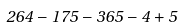Convert formula to latex. <formula><loc_0><loc_0><loc_500><loc_500>2 6 4 - 1 7 5 - 3 6 5 - 4 + 5</formula> 